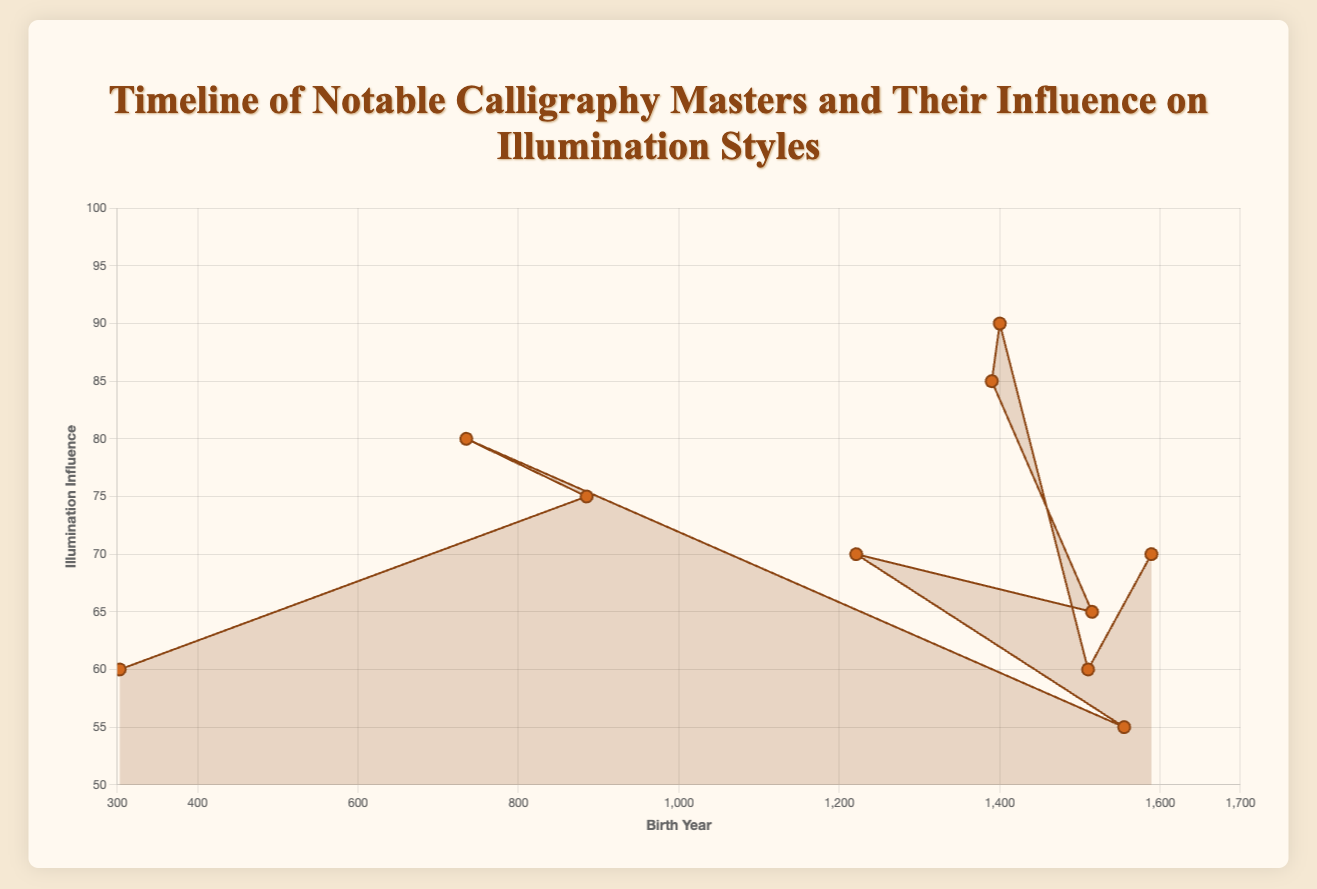Who has the highest illumination influence? Johannes Gutenberg has the highest illumination influence of 90, seen as the highest point along the y-axis on the chart.
Answer: Johannes Gutenberg Which calligraphy master had the lowest illumination influence? Dong Qichang had the lowest influence with a value of 55, indicated by one of the lower points on the y-axis in the chart.
Answer: Dong Qichang Which two calligraphy masters were born the closest in time? Johannes Gutenberg (1400) and Jan van Eyck (1390) were born closest, with a difference of only 10 years, seen as the two closest points along the x-axis in the early 1400s.
Answer: Johannes Gutenberg and Jan van Eyck How many calligraphy masters had an illumination influence of 70 or higher? There are six: Johannes Gutenberg, Jan van Eyck, Alcuin of York, Ibn Muqla, Yaqut al-Musta'simi, and Louis Barbedor. Observing the y-axis values shows these data points being at or above 70.
Answer: 6 What is the total span of birth years for all calligraphy masters? The earliest birth year is 303 (Wang Xizhi) and the latest is 1589 (Louis Barbedor). The total span is therefore 1589 - 303 = 1286 years.
Answer: 1286 years Which regions are represented more than once in the timeline? China (Wang Xizhi, Dong Qichang) and Iraq (Ibn Muqla, Yaqut al-Musta'simi) have more than one representative, seen from the repeated labels over the timeline.
Answer: China and Iraq What is the average illumination influence across all the calligraphy masters? Sum the influence values (60 + 75 + 80 + 55 + 70 + 65 + 85 + 90 + 60 + 70 = 710) and divide by the number of masters (710/10 = 71).
Answer: 71 By how many years does Ibn Muqla precede Yaqut al-Musta'simi? Yaqut al-Musta'simi was born in 1221 and Ibn Muqla in 885, so Ibn Muqla precedes by 1221 - 885 = 336 years.
Answer: 336 years Who lived the longest life, and how many years did they live? Louis Barbedor had the longest life, living for 1670 - 1589 = 81 years. Observed from the longest span between birth and death years.
Answer: Louis Barbedor 